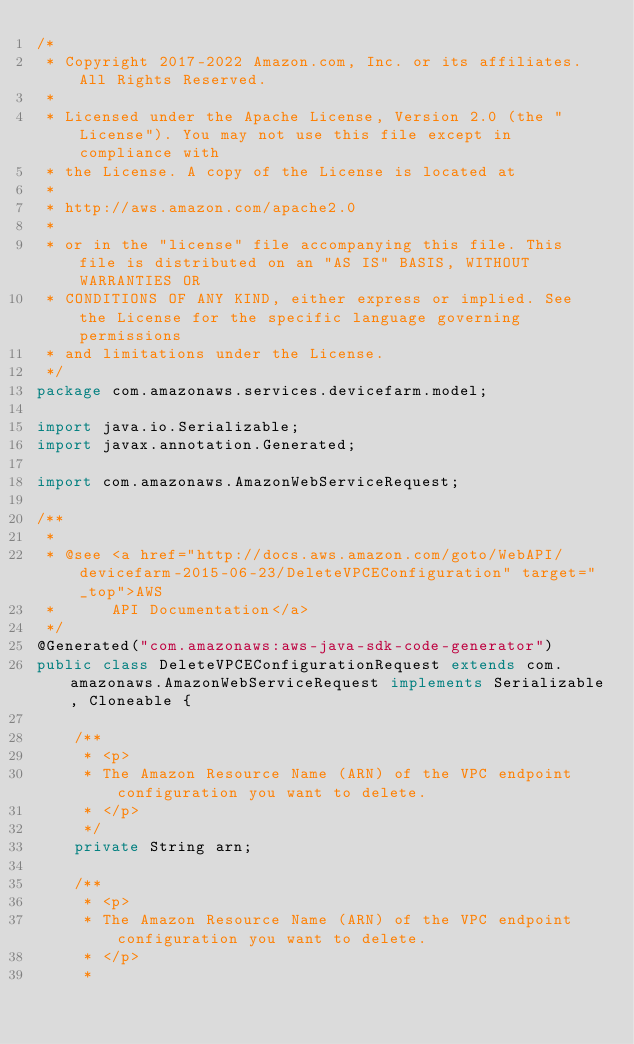<code> <loc_0><loc_0><loc_500><loc_500><_Java_>/*
 * Copyright 2017-2022 Amazon.com, Inc. or its affiliates. All Rights Reserved.
 * 
 * Licensed under the Apache License, Version 2.0 (the "License"). You may not use this file except in compliance with
 * the License. A copy of the License is located at
 * 
 * http://aws.amazon.com/apache2.0
 * 
 * or in the "license" file accompanying this file. This file is distributed on an "AS IS" BASIS, WITHOUT WARRANTIES OR
 * CONDITIONS OF ANY KIND, either express or implied. See the License for the specific language governing permissions
 * and limitations under the License.
 */
package com.amazonaws.services.devicefarm.model;

import java.io.Serializable;
import javax.annotation.Generated;

import com.amazonaws.AmazonWebServiceRequest;

/**
 * 
 * @see <a href="http://docs.aws.amazon.com/goto/WebAPI/devicefarm-2015-06-23/DeleteVPCEConfiguration" target="_top">AWS
 *      API Documentation</a>
 */
@Generated("com.amazonaws:aws-java-sdk-code-generator")
public class DeleteVPCEConfigurationRequest extends com.amazonaws.AmazonWebServiceRequest implements Serializable, Cloneable {

    /**
     * <p>
     * The Amazon Resource Name (ARN) of the VPC endpoint configuration you want to delete.
     * </p>
     */
    private String arn;

    /**
     * <p>
     * The Amazon Resource Name (ARN) of the VPC endpoint configuration you want to delete.
     * </p>
     * </code> 